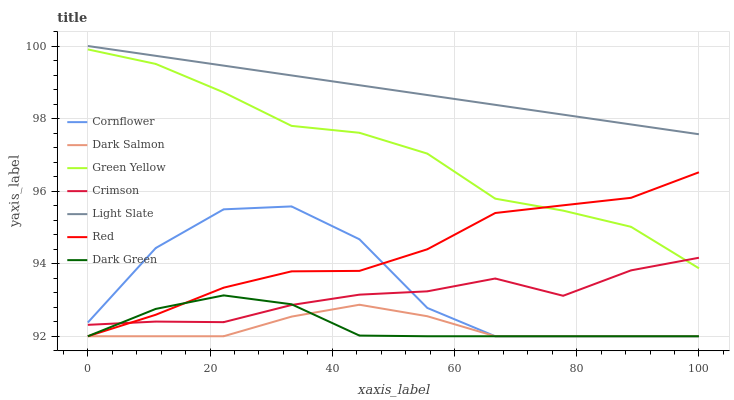Does Dark Salmon have the minimum area under the curve?
Answer yes or no. Yes. Does Light Slate have the maximum area under the curve?
Answer yes or no. Yes. Does Light Slate have the minimum area under the curve?
Answer yes or no. No. Does Dark Salmon have the maximum area under the curve?
Answer yes or no. No. Is Light Slate the smoothest?
Answer yes or no. Yes. Is Cornflower the roughest?
Answer yes or no. Yes. Is Dark Salmon the smoothest?
Answer yes or no. No. Is Dark Salmon the roughest?
Answer yes or no. No. Does Cornflower have the lowest value?
Answer yes or no. Yes. Does Light Slate have the lowest value?
Answer yes or no. No. Does Light Slate have the highest value?
Answer yes or no. Yes. Does Dark Salmon have the highest value?
Answer yes or no. No. Is Cornflower less than Green Yellow?
Answer yes or no. Yes. Is Light Slate greater than Cornflower?
Answer yes or no. Yes. Does Green Yellow intersect Red?
Answer yes or no. Yes. Is Green Yellow less than Red?
Answer yes or no. No. Is Green Yellow greater than Red?
Answer yes or no. No. Does Cornflower intersect Green Yellow?
Answer yes or no. No. 